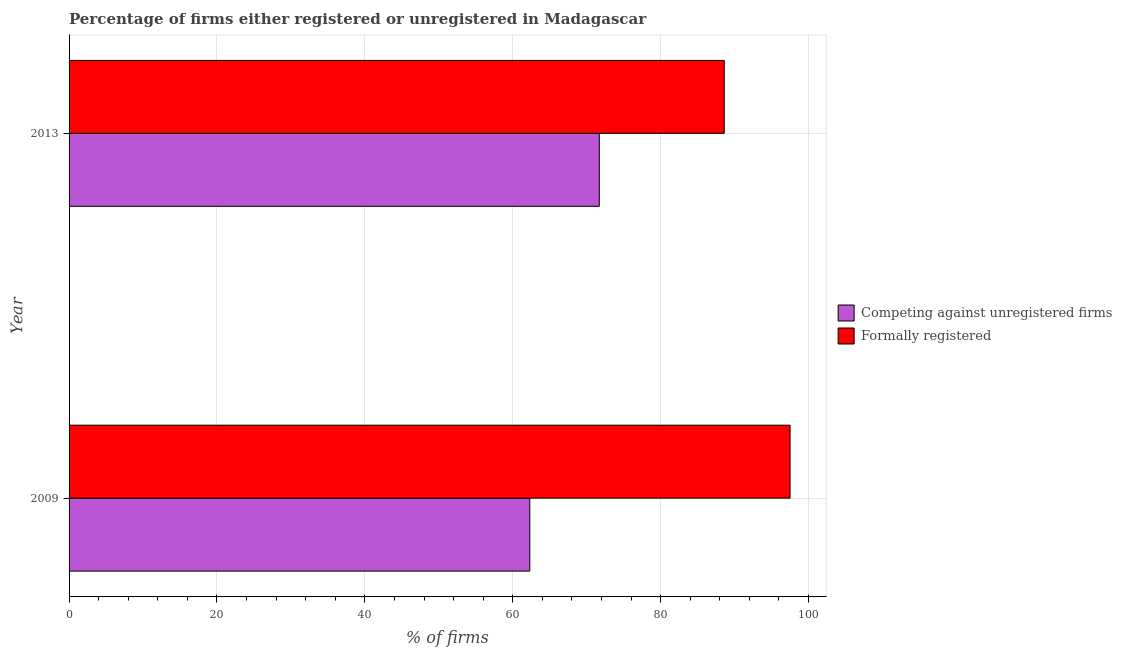How many different coloured bars are there?
Your answer should be very brief. 2. Are the number of bars per tick equal to the number of legend labels?
Make the answer very short. Yes. How many bars are there on the 1st tick from the top?
Offer a very short reply. 2. What is the percentage of registered firms in 2013?
Give a very brief answer. 71.7. Across all years, what is the maximum percentage of formally registered firms?
Provide a short and direct response. 97.5. Across all years, what is the minimum percentage of registered firms?
Keep it short and to the point. 62.3. In which year was the percentage of formally registered firms maximum?
Offer a terse response. 2009. What is the total percentage of formally registered firms in the graph?
Your response must be concise. 186.1. What is the difference between the percentage of formally registered firms in 2009 and the percentage of registered firms in 2013?
Keep it short and to the point. 25.8. What is the average percentage of registered firms per year?
Give a very brief answer. 67. In the year 2013, what is the difference between the percentage of formally registered firms and percentage of registered firms?
Keep it short and to the point. 16.9. What is the ratio of the percentage of registered firms in 2009 to that in 2013?
Your response must be concise. 0.87. Is the percentage of registered firms in 2009 less than that in 2013?
Ensure brevity in your answer.  Yes. What does the 2nd bar from the top in 2009 represents?
Offer a very short reply. Competing against unregistered firms. What does the 1st bar from the bottom in 2013 represents?
Provide a succinct answer. Competing against unregistered firms. How many bars are there?
Make the answer very short. 4. What is the difference between two consecutive major ticks on the X-axis?
Provide a succinct answer. 20. Are the values on the major ticks of X-axis written in scientific E-notation?
Provide a succinct answer. No. Does the graph contain grids?
Make the answer very short. Yes. How many legend labels are there?
Give a very brief answer. 2. What is the title of the graph?
Make the answer very short. Percentage of firms either registered or unregistered in Madagascar. What is the label or title of the X-axis?
Offer a terse response. % of firms. What is the label or title of the Y-axis?
Ensure brevity in your answer.  Year. What is the % of firms of Competing against unregistered firms in 2009?
Offer a terse response. 62.3. What is the % of firms in Formally registered in 2009?
Ensure brevity in your answer.  97.5. What is the % of firms of Competing against unregistered firms in 2013?
Give a very brief answer. 71.7. What is the % of firms in Formally registered in 2013?
Provide a short and direct response. 88.6. Across all years, what is the maximum % of firms in Competing against unregistered firms?
Ensure brevity in your answer.  71.7. Across all years, what is the maximum % of firms of Formally registered?
Give a very brief answer. 97.5. Across all years, what is the minimum % of firms in Competing against unregistered firms?
Make the answer very short. 62.3. Across all years, what is the minimum % of firms in Formally registered?
Keep it short and to the point. 88.6. What is the total % of firms of Competing against unregistered firms in the graph?
Your answer should be very brief. 134. What is the total % of firms of Formally registered in the graph?
Provide a short and direct response. 186.1. What is the difference between the % of firms in Competing against unregistered firms in 2009 and the % of firms in Formally registered in 2013?
Keep it short and to the point. -26.3. What is the average % of firms in Formally registered per year?
Ensure brevity in your answer.  93.05. In the year 2009, what is the difference between the % of firms in Competing against unregistered firms and % of firms in Formally registered?
Your answer should be very brief. -35.2. In the year 2013, what is the difference between the % of firms of Competing against unregistered firms and % of firms of Formally registered?
Your answer should be very brief. -16.9. What is the ratio of the % of firms of Competing against unregistered firms in 2009 to that in 2013?
Ensure brevity in your answer.  0.87. What is the ratio of the % of firms in Formally registered in 2009 to that in 2013?
Ensure brevity in your answer.  1.1. What is the difference between the highest and the second highest % of firms of Formally registered?
Provide a succinct answer. 8.9. What is the difference between the highest and the lowest % of firms of Competing against unregistered firms?
Provide a succinct answer. 9.4. What is the difference between the highest and the lowest % of firms of Formally registered?
Make the answer very short. 8.9. 